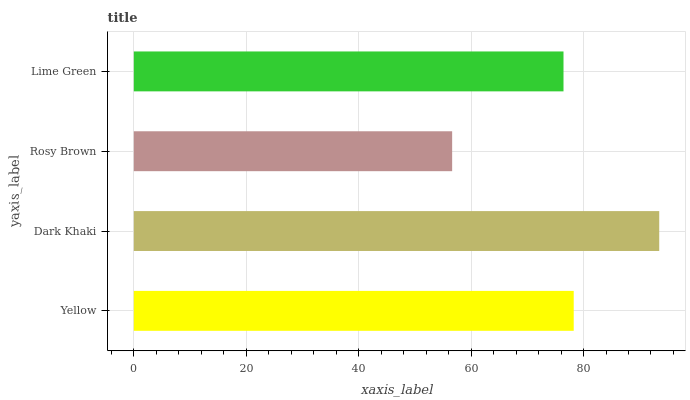Is Rosy Brown the minimum?
Answer yes or no. Yes. Is Dark Khaki the maximum?
Answer yes or no. Yes. Is Dark Khaki the minimum?
Answer yes or no. No. Is Rosy Brown the maximum?
Answer yes or no. No. Is Dark Khaki greater than Rosy Brown?
Answer yes or no. Yes. Is Rosy Brown less than Dark Khaki?
Answer yes or no. Yes. Is Rosy Brown greater than Dark Khaki?
Answer yes or no. No. Is Dark Khaki less than Rosy Brown?
Answer yes or no. No. Is Yellow the high median?
Answer yes or no. Yes. Is Lime Green the low median?
Answer yes or no. Yes. Is Rosy Brown the high median?
Answer yes or no. No. Is Dark Khaki the low median?
Answer yes or no. No. 